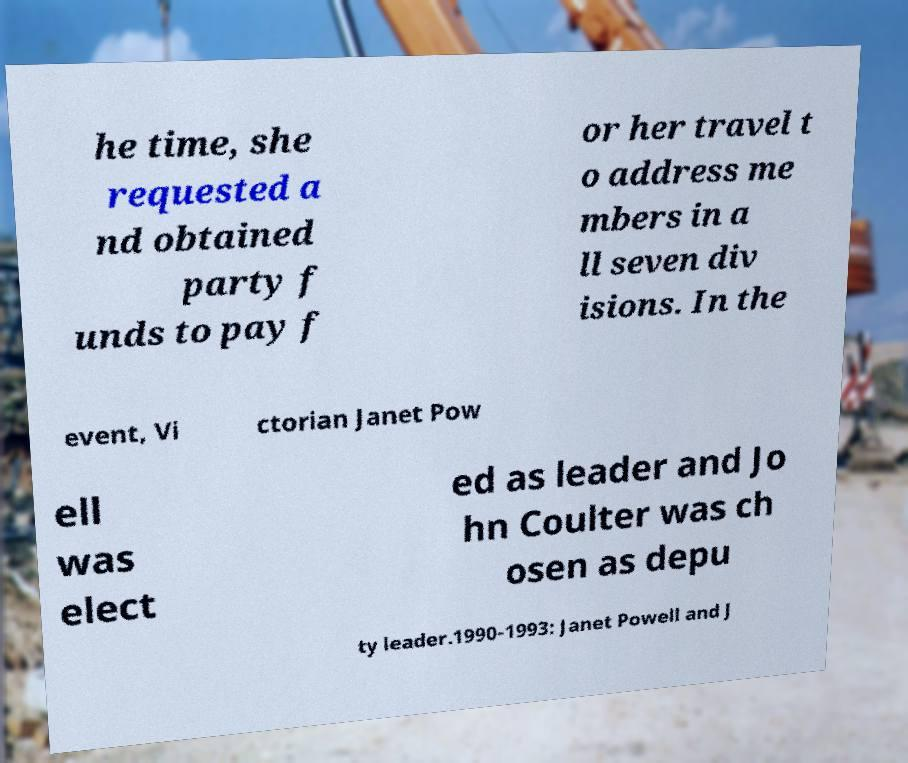Please read and relay the text visible in this image. What does it say? he time, she requested a nd obtained party f unds to pay f or her travel t o address me mbers in a ll seven div isions. In the event, Vi ctorian Janet Pow ell was elect ed as leader and Jo hn Coulter was ch osen as depu ty leader.1990-1993: Janet Powell and J 